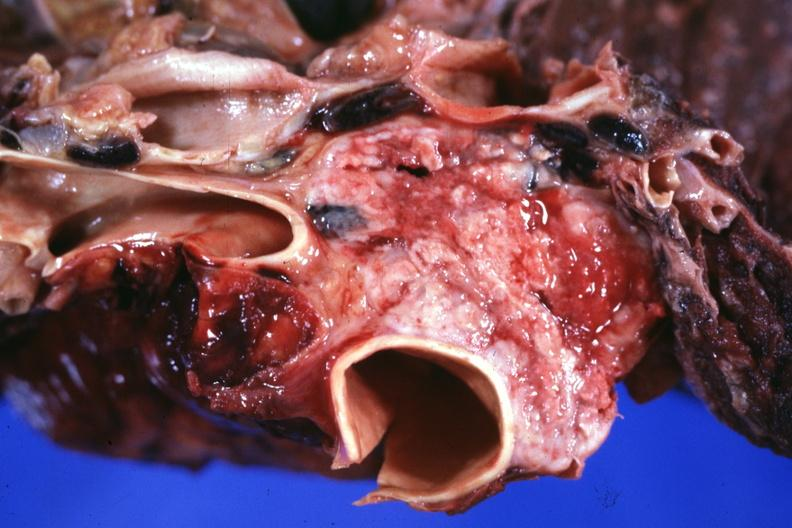s malignant thymoma present?
Answer the question using a single word or phrase. Yes 